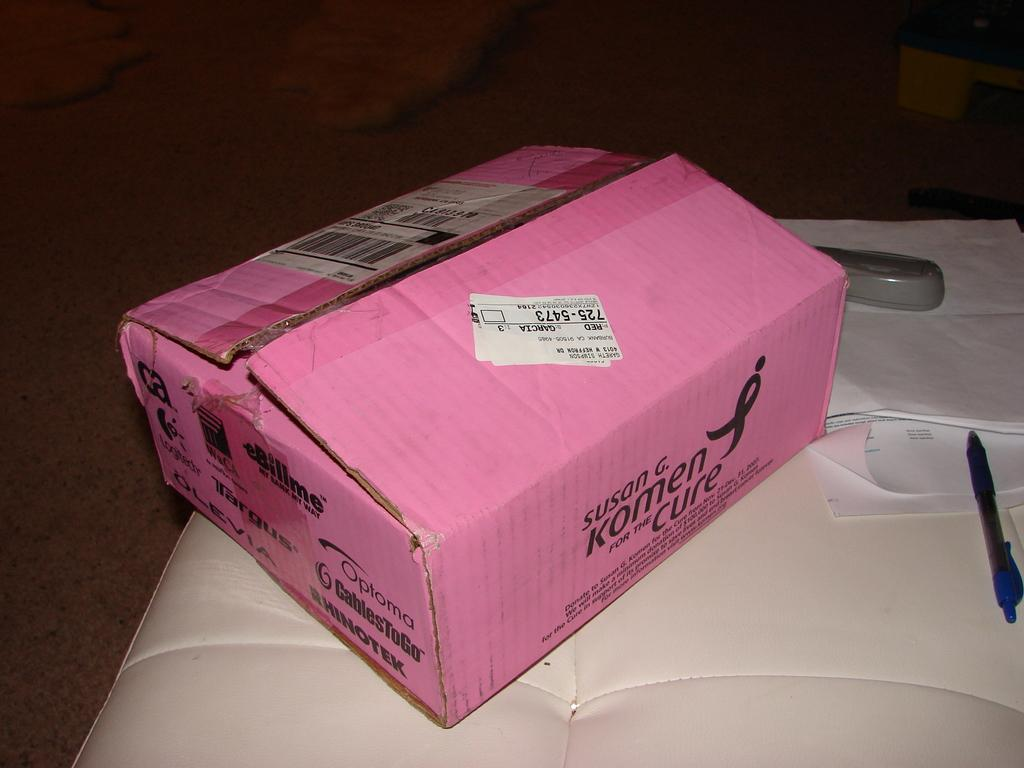<image>
Provide a brief description of the given image. a  pink shipping box supporting susan G Komen and the cure 